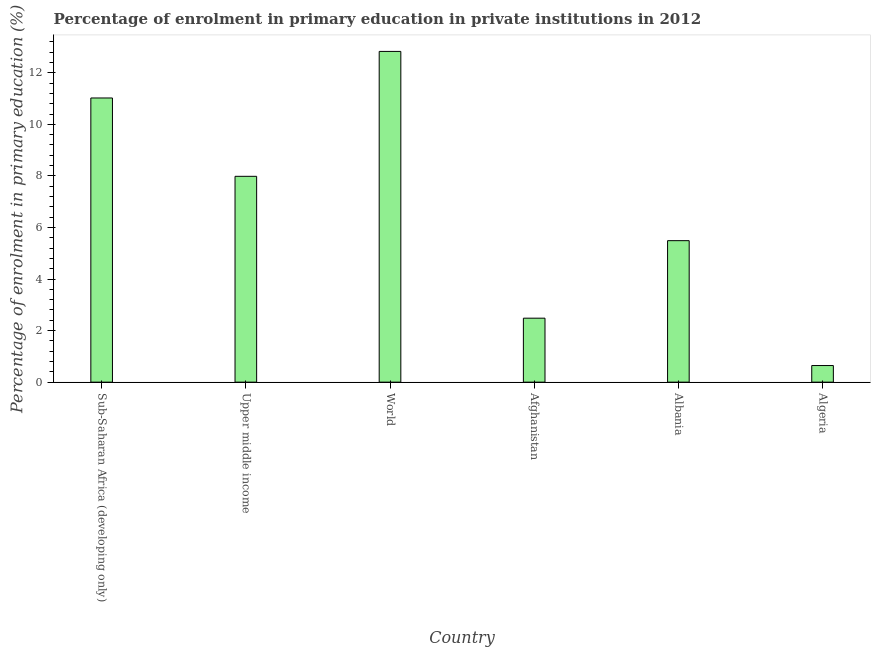Does the graph contain any zero values?
Your answer should be compact. No. What is the title of the graph?
Keep it short and to the point. Percentage of enrolment in primary education in private institutions in 2012. What is the label or title of the Y-axis?
Make the answer very short. Percentage of enrolment in primary education (%). What is the enrolment percentage in primary education in Upper middle income?
Make the answer very short. 7.98. Across all countries, what is the maximum enrolment percentage in primary education?
Your answer should be compact. 12.83. Across all countries, what is the minimum enrolment percentage in primary education?
Your answer should be very brief. 0.64. In which country was the enrolment percentage in primary education minimum?
Provide a succinct answer. Algeria. What is the sum of the enrolment percentage in primary education?
Offer a very short reply. 40.45. What is the difference between the enrolment percentage in primary education in Algeria and World?
Your response must be concise. -12.18. What is the average enrolment percentage in primary education per country?
Offer a terse response. 6.74. What is the median enrolment percentage in primary education?
Make the answer very short. 6.74. In how many countries, is the enrolment percentage in primary education greater than 10.8 %?
Your response must be concise. 2. What is the ratio of the enrolment percentage in primary education in Albania to that in Upper middle income?
Ensure brevity in your answer.  0.69. What is the difference between the highest and the second highest enrolment percentage in primary education?
Keep it short and to the point. 1.81. Is the sum of the enrolment percentage in primary education in Albania and Upper middle income greater than the maximum enrolment percentage in primary education across all countries?
Provide a succinct answer. Yes. What is the difference between the highest and the lowest enrolment percentage in primary education?
Keep it short and to the point. 12.18. In how many countries, is the enrolment percentage in primary education greater than the average enrolment percentage in primary education taken over all countries?
Give a very brief answer. 3. How many bars are there?
Your response must be concise. 6. What is the difference between two consecutive major ticks on the Y-axis?
Your answer should be compact. 2. Are the values on the major ticks of Y-axis written in scientific E-notation?
Your response must be concise. No. What is the Percentage of enrolment in primary education (%) of Sub-Saharan Africa (developing only)?
Provide a short and direct response. 11.02. What is the Percentage of enrolment in primary education (%) of Upper middle income?
Your answer should be very brief. 7.98. What is the Percentage of enrolment in primary education (%) of World?
Make the answer very short. 12.83. What is the Percentage of enrolment in primary education (%) in Afghanistan?
Your answer should be very brief. 2.48. What is the Percentage of enrolment in primary education (%) in Albania?
Provide a short and direct response. 5.49. What is the Percentage of enrolment in primary education (%) of Algeria?
Provide a succinct answer. 0.64. What is the difference between the Percentage of enrolment in primary education (%) in Sub-Saharan Africa (developing only) and Upper middle income?
Give a very brief answer. 3.04. What is the difference between the Percentage of enrolment in primary education (%) in Sub-Saharan Africa (developing only) and World?
Provide a short and direct response. -1.81. What is the difference between the Percentage of enrolment in primary education (%) in Sub-Saharan Africa (developing only) and Afghanistan?
Your answer should be very brief. 8.54. What is the difference between the Percentage of enrolment in primary education (%) in Sub-Saharan Africa (developing only) and Albania?
Make the answer very short. 5.53. What is the difference between the Percentage of enrolment in primary education (%) in Sub-Saharan Africa (developing only) and Algeria?
Your answer should be very brief. 10.38. What is the difference between the Percentage of enrolment in primary education (%) in Upper middle income and World?
Your answer should be compact. -4.84. What is the difference between the Percentage of enrolment in primary education (%) in Upper middle income and Afghanistan?
Your answer should be very brief. 5.5. What is the difference between the Percentage of enrolment in primary education (%) in Upper middle income and Albania?
Your answer should be very brief. 2.5. What is the difference between the Percentage of enrolment in primary education (%) in Upper middle income and Algeria?
Your answer should be very brief. 7.34. What is the difference between the Percentage of enrolment in primary education (%) in World and Afghanistan?
Your answer should be compact. 10.35. What is the difference between the Percentage of enrolment in primary education (%) in World and Albania?
Offer a terse response. 7.34. What is the difference between the Percentage of enrolment in primary education (%) in World and Algeria?
Your answer should be very brief. 12.18. What is the difference between the Percentage of enrolment in primary education (%) in Afghanistan and Albania?
Provide a succinct answer. -3.01. What is the difference between the Percentage of enrolment in primary education (%) in Afghanistan and Algeria?
Make the answer very short. 1.84. What is the difference between the Percentage of enrolment in primary education (%) in Albania and Algeria?
Offer a very short reply. 4.84. What is the ratio of the Percentage of enrolment in primary education (%) in Sub-Saharan Africa (developing only) to that in Upper middle income?
Provide a succinct answer. 1.38. What is the ratio of the Percentage of enrolment in primary education (%) in Sub-Saharan Africa (developing only) to that in World?
Offer a very short reply. 0.86. What is the ratio of the Percentage of enrolment in primary education (%) in Sub-Saharan Africa (developing only) to that in Afghanistan?
Ensure brevity in your answer.  4.44. What is the ratio of the Percentage of enrolment in primary education (%) in Sub-Saharan Africa (developing only) to that in Albania?
Offer a very short reply. 2.01. What is the ratio of the Percentage of enrolment in primary education (%) in Sub-Saharan Africa (developing only) to that in Algeria?
Offer a terse response. 17.12. What is the ratio of the Percentage of enrolment in primary education (%) in Upper middle income to that in World?
Your answer should be very brief. 0.62. What is the ratio of the Percentage of enrolment in primary education (%) in Upper middle income to that in Afghanistan?
Your answer should be very brief. 3.22. What is the ratio of the Percentage of enrolment in primary education (%) in Upper middle income to that in Albania?
Your answer should be very brief. 1.46. What is the ratio of the Percentage of enrolment in primary education (%) in Upper middle income to that in Algeria?
Ensure brevity in your answer.  12.4. What is the ratio of the Percentage of enrolment in primary education (%) in World to that in Afghanistan?
Your answer should be compact. 5.17. What is the ratio of the Percentage of enrolment in primary education (%) in World to that in Albania?
Your answer should be very brief. 2.34. What is the ratio of the Percentage of enrolment in primary education (%) in World to that in Algeria?
Keep it short and to the point. 19.92. What is the ratio of the Percentage of enrolment in primary education (%) in Afghanistan to that in Albania?
Provide a short and direct response. 0.45. What is the ratio of the Percentage of enrolment in primary education (%) in Afghanistan to that in Algeria?
Offer a very short reply. 3.85. What is the ratio of the Percentage of enrolment in primary education (%) in Albania to that in Algeria?
Your answer should be very brief. 8.52. 